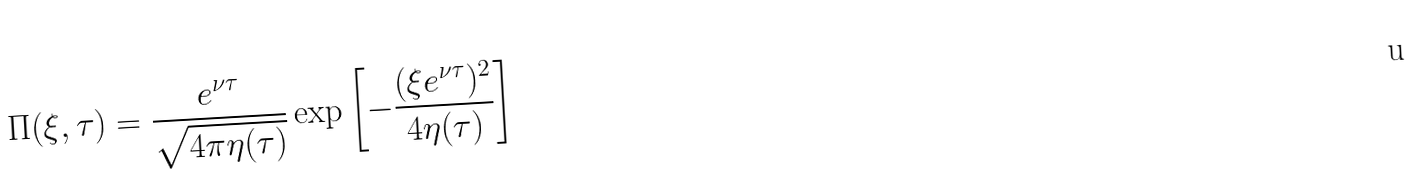Convert formula to latex. <formula><loc_0><loc_0><loc_500><loc_500>\Pi ( \xi , \tau ) = \frac { e ^ { \nu \tau } } { \sqrt { 4 \pi \eta ( \tau ) } } \exp \left [ - \frac { ( \xi e ^ { \nu \tau } ) ^ { 2 } } { 4 \eta ( \tau ) } \right ]</formula> 